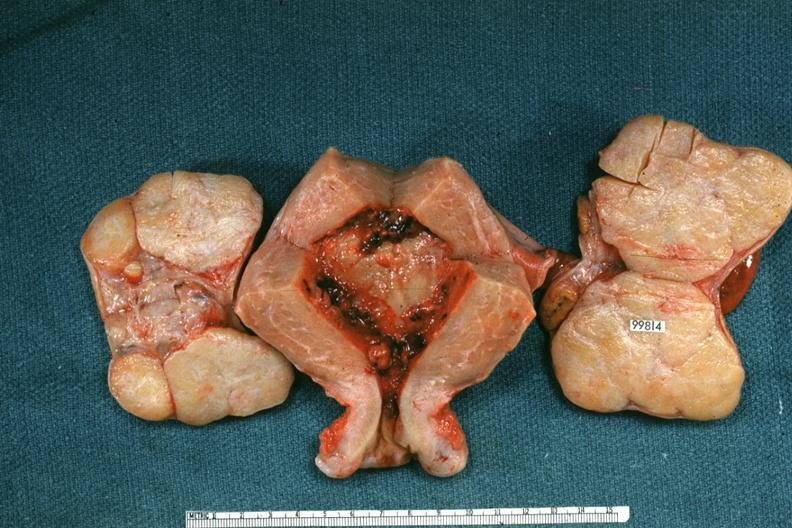s female reproductive present?
Answer the question using a single word or phrase. Yes 